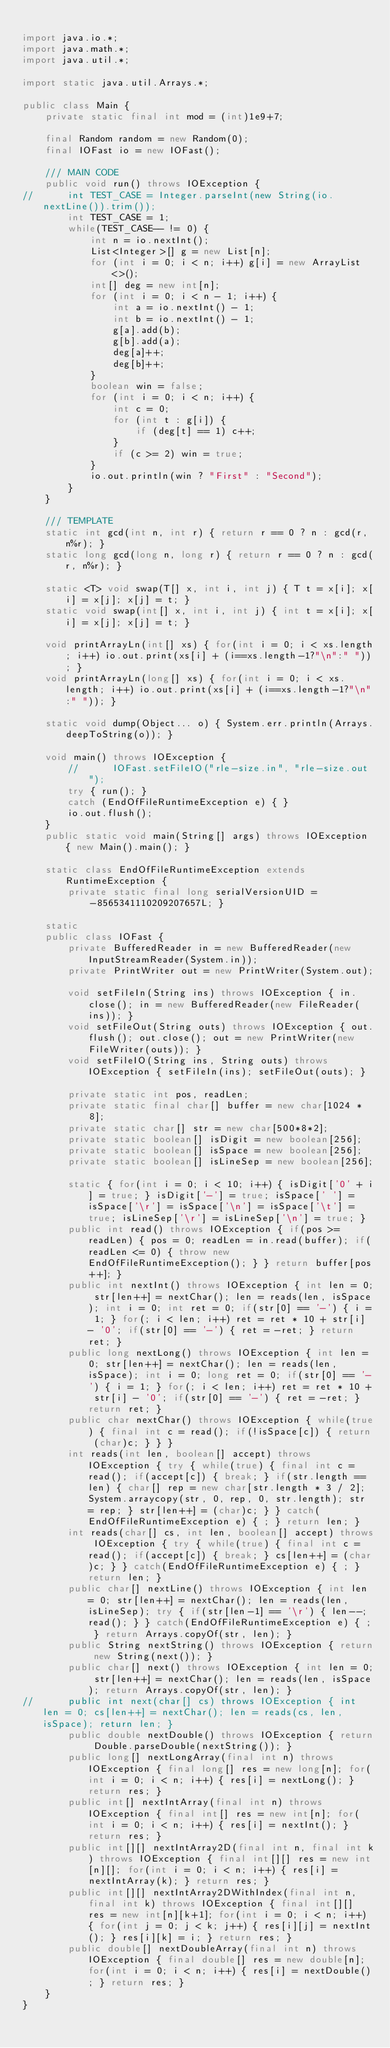<code> <loc_0><loc_0><loc_500><loc_500><_Java_>
import java.io.*;
import java.math.*;
import java.util.*;

import static java.util.Arrays.*;

public class Main {
	private static final int mod = (int)1e9+7;

	final Random random = new Random(0);
	final IOFast io = new IOFast();

	/// MAIN CODE
	public void run() throws IOException {
//		int TEST_CASE = Integer.parseInt(new String(io.nextLine()).trim());
		int TEST_CASE = 1;
		while(TEST_CASE-- != 0) {
			int n = io.nextInt();
			List<Integer>[] g = new List[n];
			for (int i = 0; i < n; i++) g[i] = new ArrayList<>();
			int[] deg = new int[n];
			for (int i = 0; i < n - 1; i++) {
				int a = io.nextInt() - 1;
				int b = io.nextInt() - 1;
				g[a].add(b);
				g[b].add(a);
				deg[a]++;
				deg[b]++;
			}
			boolean win = false;
			for (int i = 0; i < n; i++) {
				int c = 0;
				for (int t : g[i]) {
					if (deg[t] == 1) c++;
				}
				if (c >= 2) win = true;
			}
			io.out.println(win ? "First" : "Second");
		}
	}

	/// TEMPLATE
	static int gcd(int n, int r) { return r == 0 ? n : gcd(r, n%r); }
	static long gcd(long n, long r) { return r == 0 ? n : gcd(r, n%r); }
	
	static <T> void swap(T[] x, int i, int j) { T t = x[i]; x[i] = x[j]; x[j] = t; }
	static void swap(int[] x, int i, int j) { int t = x[i]; x[i] = x[j]; x[j] = t; }

	void printArrayLn(int[] xs) { for(int i = 0; i < xs.length; i++) io.out.print(xs[i] + (i==xs.length-1?"\n":" ")); }
	void printArrayLn(long[] xs) { for(int i = 0; i < xs.length; i++) io.out.print(xs[i] + (i==xs.length-1?"\n":" ")); }
	
	static void dump(Object... o) { System.err.println(Arrays.deepToString(o)); } 
	
	void main() throws IOException {
		//		IOFast.setFileIO("rle-size.in", "rle-size.out");
		try { run(); }
		catch (EndOfFileRuntimeException e) { }
		io.out.flush();
	}
	public static void main(String[] args) throws IOException { new Main().main(); }
	
	static class EndOfFileRuntimeException extends RuntimeException {
		private static final long serialVersionUID = -8565341110209207657L; }

	static
	public class IOFast {
		private BufferedReader in = new BufferedReader(new InputStreamReader(System.in));
		private PrintWriter out = new PrintWriter(System.out);

		void setFileIn(String ins) throws IOException { in.close(); in = new BufferedReader(new FileReader(ins)); }
		void setFileOut(String outs) throws IOException { out.flush(); out.close(); out = new PrintWriter(new FileWriter(outs)); }
		void setFileIO(String ins, String outs) throws IOException { setFileIn(ins); setFileOut(outs); }

		private static int pos, readLen;
		private static final char[] buffer = new char[1024 * 8];
		private static char[] str = new char[500*8*2];
		private static boolean[] isDigit = new boolean[256];
		private static boolean[] isSpace = new boolean[256];
		private static boolean[] isLineSep = new boolean[256];

		static { for(int i = 0; i < 10; i++) { isDigit['0' + i] = true; } isDigit['-'] = true; isSpace[' '] = isSpace['\r'] = isSpace['\n'] = isSpace['\t'] = true; isLineSep['\r'] = isLineSep['\n'] = true; }
		public int read() throws IOException { if(pos >= readLen) { pos = 0; readLen = in.read(buffer); if(readLen <= 0) { throw new EndOfFileRuntimeException(); } } return buffer[pos++]; }
		public int nextInt() throws IOException { int len = 0; str[len++] = nextChar(); len = reads(len, isSpace); int i = 0; int ret = 0; if(str[0] == '-') { i = 1; } for(; i < len; i++) ret = ret * 10 + str[i] - '0'; if(str[0] == '-') { ret = -ret; } return ret; }
		public long nextLong() throws IOException { int len = 0; str[len++] = nextChar(); len = reads(len, isSpace); int i = 0; long ret = 0; if(str[0] == '-') { i = 1; } for(; i < len; i++) ret = ret * 10 + str[i] - '0'; if(str[0] == '-') { ret = -ret; } return ret; }
		public char nextChar() throws IOException { while(true) { final int c = read(); if(!isSpace[c]) { return (char)c; } } }
		int reads(int len, boolean[] accept) throws IOException { try { while(true) { final int c = read(); if(accept[c]) { break; } if(str.length == len) { char[] rep = new char[str.length * 3 / 2]; System.arraycopy(str, 0, rep, 0, str.length); str = rep; } str[len++] = (char)c; } } catch(EndOfFileRuntimeException e) { ; } return len; }
		int reads(char[] cs, int len, boolean[] accept) throws IOException { try { while(true) { final int c = read(); if(accept[c]) { break; } cs[len++] = (char)c; } } catch(EndOfFileRuntimeException e) { ; } return len; }
		public char[] nextLine() throws IOException { int len = 0; str[len++] = nextChar(); len = reads(len, isLineSep); try { if(str[len-1] == '\r') { len--; read(); } } catch(EndOfFileRuntimeException e) { ; } return Arrays.copyOf(str, len); }
		public String nextString() throws IOException { return new String(next()); }
		public char[] next() throws IOException { int len = 0; str[len++] = nextChar(); len = reads(len, isSpace); return Arrays.copyOf(str, len); }
//		public int next(char[] cs) throws IOException { int len = 0; cs[len++] = nextChar(); len = reads(cs, len, isSpace); return len; }
		public double nextDouble() throws IOException { return Double.parseDouble(nextString()); }
		public long[] nextLongArray(final int n) throws IOException { final long[] res = new long[n]; for(int i = 0; i < n; i++) { res[i] = nextLong(); } return res; }
		public int[] nextIntArray(final int n) throws IOException { final int[] res = new int[n]; for(int i = 0; i < n; i++) { res[i] = nextInt(); } return res; }
		public int[][] nextIntArray2D(final int n, final int k) throws IOException { final int[][] res = new int[n][]; for(int i = 0; i < n; i++) { res[i] = nextIntArray(k); } return res; }
		public int[][] nextIntArray2DWithIndex(final int n, final int k) throws IOException { final int[][] res = new int[n][k+1]; for(int i = 0; i < n; i++) { for(int j = 0; j < k; j++) { res[i][j] = nextInt(); } res[i][k] = i; } return res; }
		public double[] nextDoubleArray(final int n) throws IOException { final double[] res = new double[n]; for(int i = 0; i < n; i++) { res[i] = nextDouble(); } return res; }
	}
}
</code> 